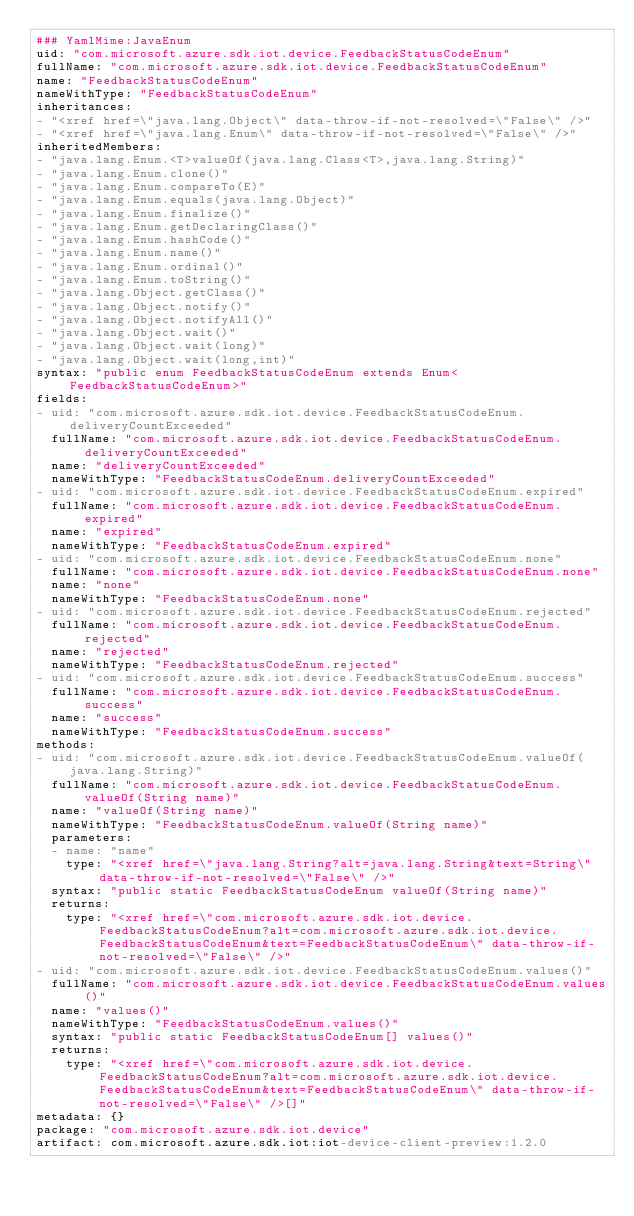Convert code to text. <code><loc_0><loc_0><loc_500><loc_500><_YAML_>### YamlMime:JavaEnum
uid: "com.microsoft.azure.sdk.iot.device.FeedbackStatusCodeEnum"
fullName: "com.microsoft.azure.sdk.iot.device.FeedbackStatusCodeEnum"
name: "FeedbackStatusCodeEnum"
nameWithType: "FeedbackStatusCodeEnum"
inheritances:
- "<xref href=\"java.lang.Object\" data-throw-if-not-resolved=\"False\" />"
- "<xref href=\"java.lang.Enum\" data-throw-if-not-resolved=\"False\" />"
inheritedMembers:
- "java.lang.Enum.<T>valueOf(java.lang.Class<T>,java.lang.String)"
- "java.lang.Enum.clone()"
- "java.lang.Enum.compareTo(E)"
- "java.lang.Enum.equals(java.lang.Object)"
- "java.lang.Enum.finalize()"
- "java.lang.Enum.getDeclaringClass()"
- "java.lang.Enum.hashCode()"
- "java.lang.Enum.name()"
- "java.lang.Enum.ordinal()"
- "java.lang.Enum.toString()"
- "java.lang.Object.getClass()"
- "java.lang.Object.notify()"
- "java.lang.Object.notifyAll()"
- "java.lang.Object.wait()"
- "java.lang.Object.wait(long)"
- "java.lang.Object.wait(long,int)"
syntax: "public enum FeedbackStatusCodeEnum extends Enum<FeedbackStatusCodeEnum>"
fields:
- uid: "com.microsoft.azure.sdk.iot.device.FeedbackStatusCodeEnum.deliveryCountExceeded"
  fullName: "com.microsoft.azure.sdk.iot.device.FeedbackStatusCodeEnum.deliveryCountExceeded"
  name: "deliveryCountExceeded"
  nameWithType: "FeedbackStatusCodeEnum.deliveryCountExceeded"
- uid: "com.microsoft.azure.sdk.iot.device.FeedbackStatusCodeEnum.expired"
  fullName: "com.microsoft.azure.sdk.iot.device.FeedbackStatusCodeEnum.expired"
  name: "expired"
  nameWithType: "FeedbackStatusCodeEnum.expired"
- uid: "com.microsoft.azure.sdk.iot.device.FeedbackStatusCodeEnum.none"
  fullName: "com.microsoft.azure.sdk.iot.device.FeedbackStatusCodeEnum.none"
  name: "none"
  nameWithType: "FeedbackStatusCodeEnum.none"
- uid: "com.microsoft.azure.sdk.iot.device.FeedbackStatusCodeEnum.rejected"
  fullName: "com.microsoft.azure.sdk.iot.device.FeedbackStatusCodeEnum.rejected"
  name: "rejected"
  nameWithType: "FeedbackStatusCodeEnum.rejected"
- uid: "com.microsoft.azure.sdk.iot.device.FeedbackStatusCodeEnum.success"
  fullName: "com.microsoft.azure.sdk.iot.device.FeedbackStatusCodeEnum.success"
  name: "success"
  nameWithType: "FeedbackStatusCodeEnum.success"
methods:
- uid: "com.microsoft.azure.sdk.iot.device.FeedbackStatusCodeEnum.valueOf(java.lang.String)"
  fullName: "com.microsoft.azure.sdk.iot.device.FeedbackStatusCodeEnum.valueOf(String name)"
  name: "valueOf(String name)"
  nameWithType: "FeedbackStatusCodeEnum.valueOf(String name)"
  parameters:
  - name: "name"
    type: "<xref href=\"java.lang.String?alt=java.lang.String&text=String\" data-throw-if-not-resolved=\"False\" />"
  syntax: "public static FeedbackStatusCodeEnum valueOf(String name)"
  returns:
    type: "<xref href=\"com.microsoft.azure.sdk.iot.device.FeedbackStatusCodeEnum?alt=com.microsoft.azure.sdk.iot.device.FeedbackStatusCodeEnum&text=FeedbackStatusCodeEnum\" data-throw-if-not-resolved=\"False\" />"
- uid: "com.microsoft.azure.sdk.iot.device.FeedbackStatusCodeEnum.values()"
  fullName: "com.microsoft.azure.sdk.iot.device.FeedbackStatusCodeEnum.values()"
  name: "values()"
  nameWithType: "FeedbackStatusCodeEnum.values()"
  syntax: "public static FeedbackStatusCodeEnum[] values()"
  returns:
    type: "<xref href=\"com.microsoft.azure.sdk.iot.device.FeedbackStatusCodeEnum?alt=com.microsoft.azure.sdk.iot.device.FeedbackStatusCodeEnum&text=FeedbackStatusCodeEnum\" data-throw-if-not-resolved=\"False\" />[]"
metadata: {}
package: "com.microsoft.azure.sdk.iot.device"
artifact: com.microsoft.azure.sdk.iot:iot-device-client-preview:1.2.0
</code> 